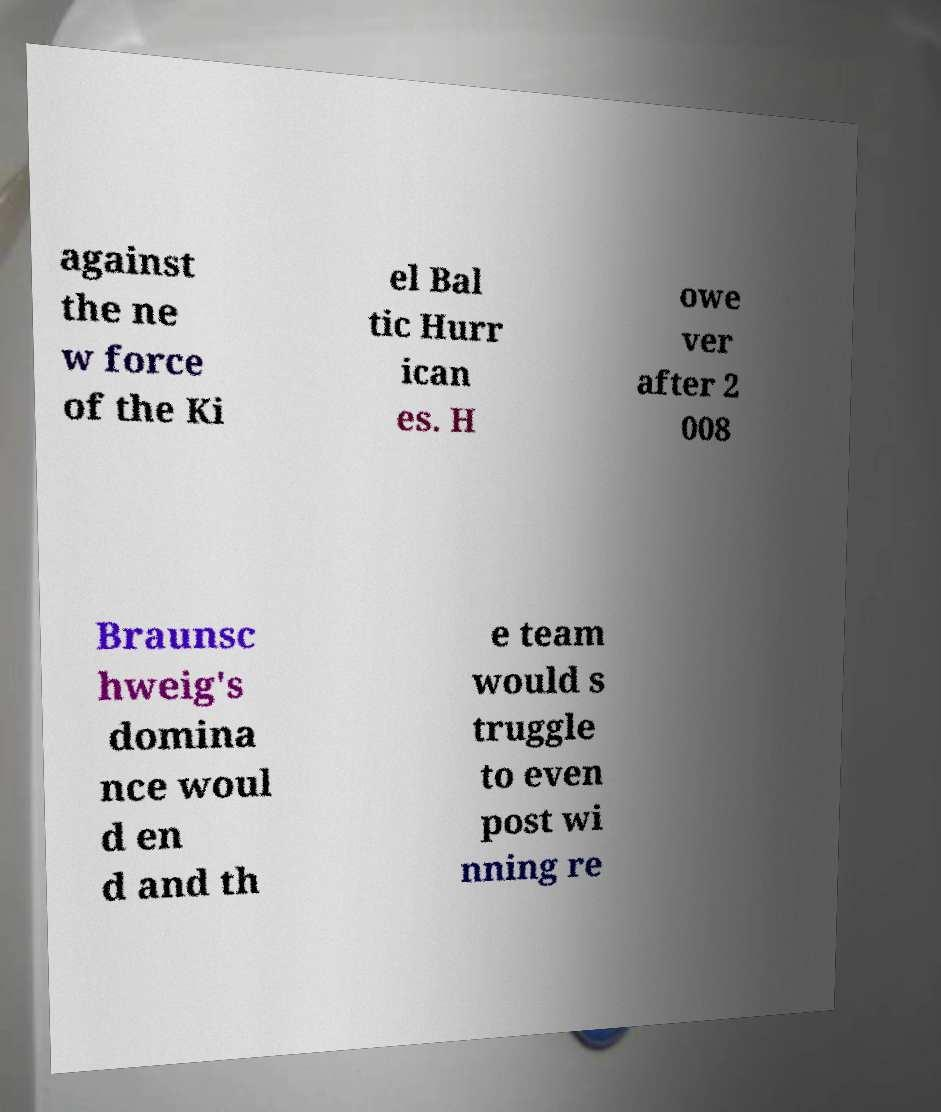For documentation purposes, I need the text within this image transcribed. Could you provide that? against the ne w force of the Ki el Bal tic Hurr ican es. H owe ver after 2 008 Braunsc hweig's domina nce woul d en d and th e team would s truggle to even post wi nning re 